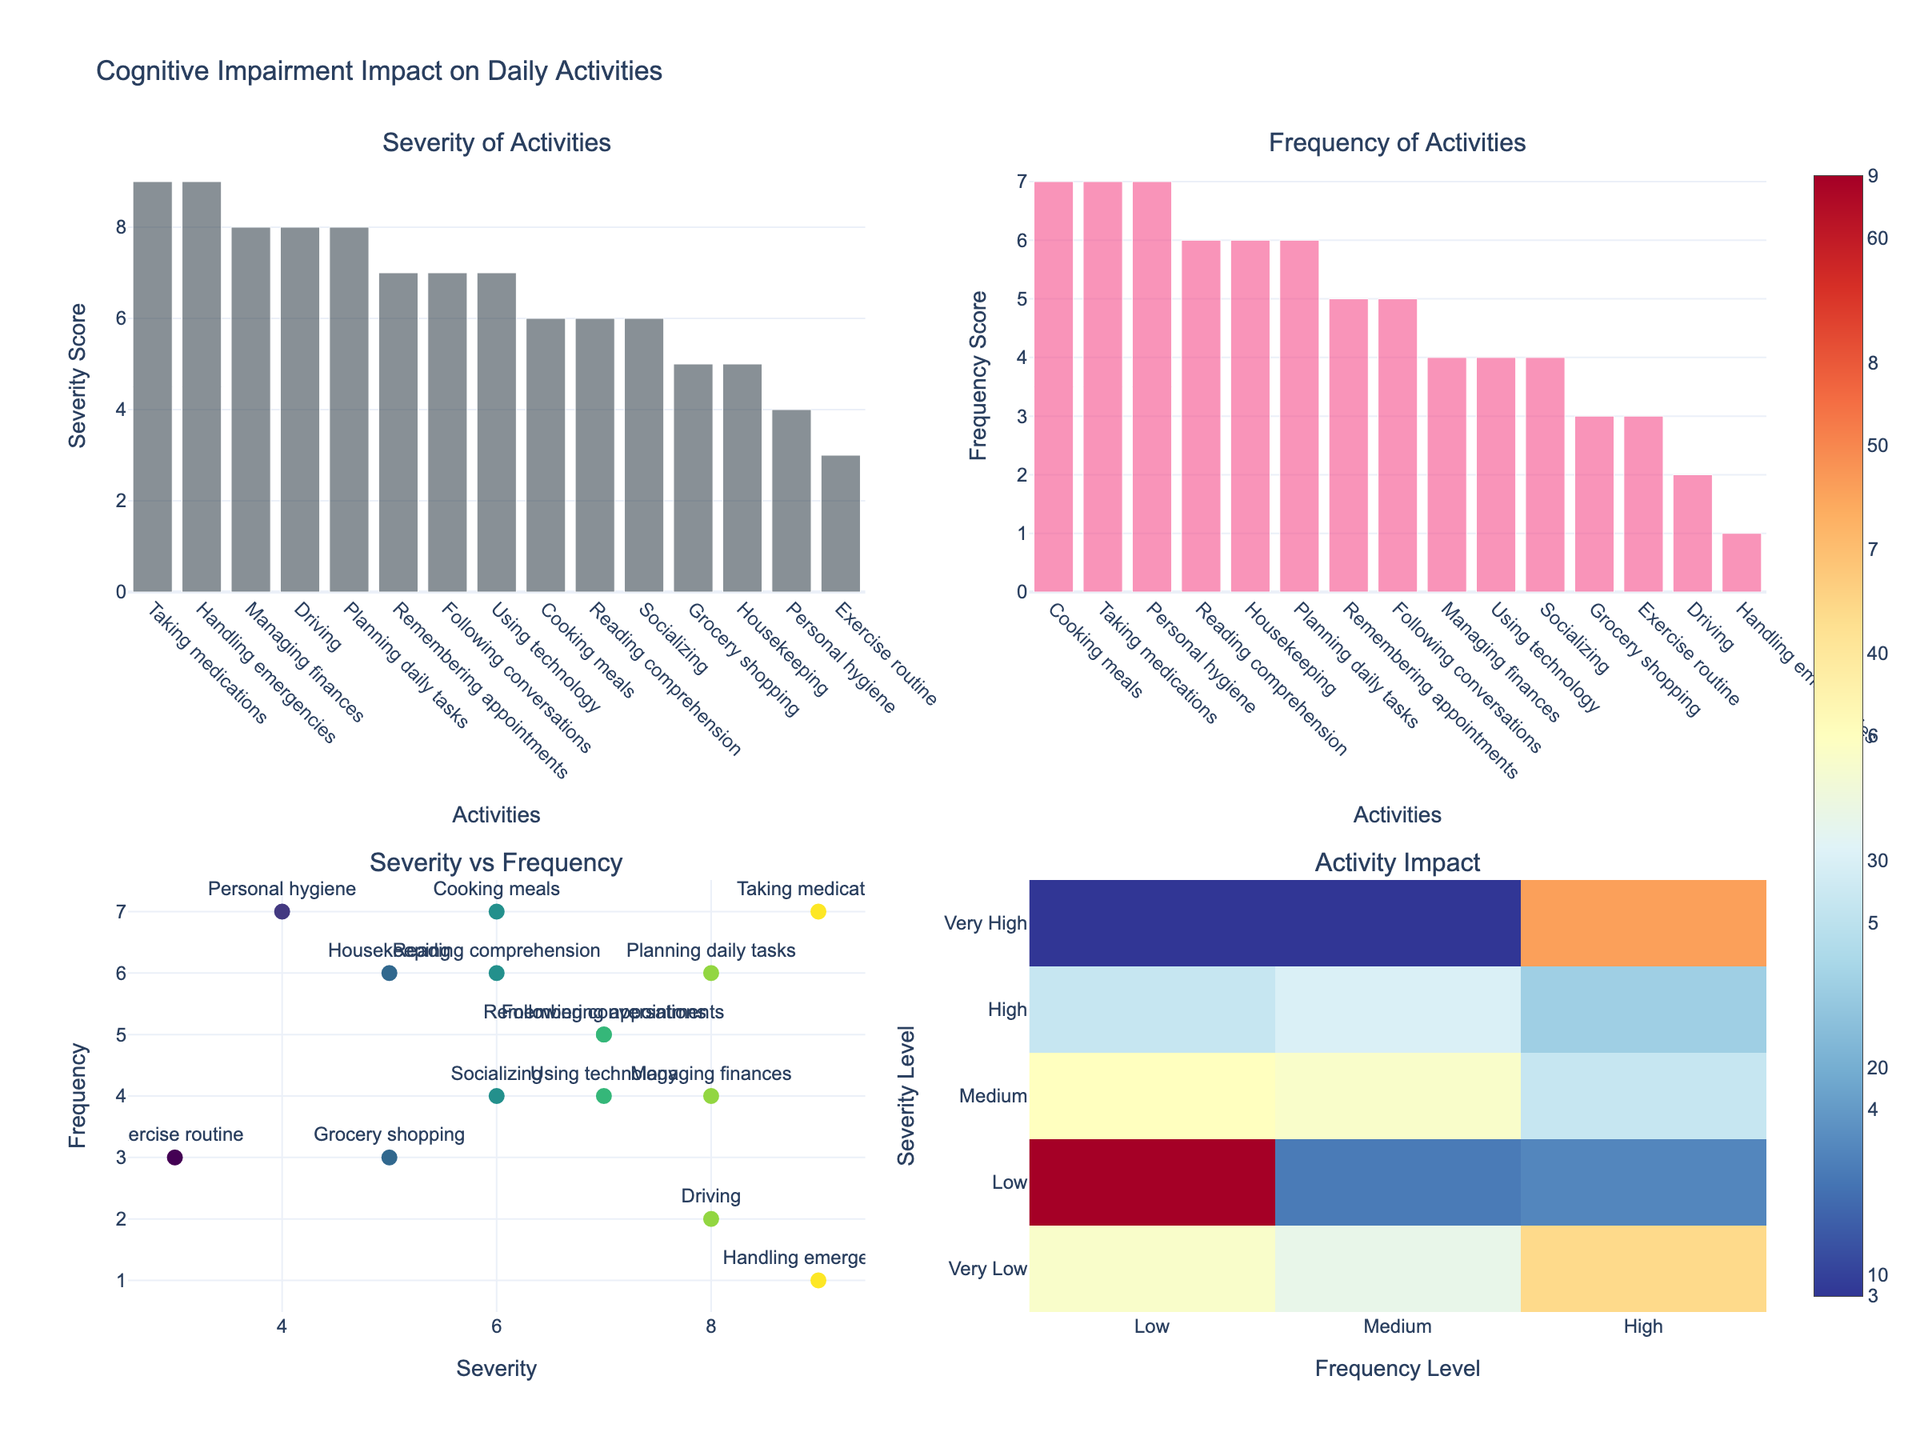What is the title of the figure? The title is usually located at the top of the plot, summarizing the contents. Here, it's located at the top.
Answer: Cognitive Impairment Impact on Daily Activities Which activity has the highest severity? To identify the activity with the highest severity, look at the first subplot (Severity of Activities) and find the tallest bar. This bar represents the activity with the highest severity score.
Answer: Taking medications What is the average frequency of daily activities? To find the average frequency, sum all the frequency values and divide by the number of activities. Frequencies are: 5, 4, 7, 7, 3, 2, 6, 5, 4, 7, 6, 4, 3, 1, and 6. Sum = 70. Number of activities = 15.
Answer: 4.67 Which activity appears to have the lowest impact according to the heatmap? In the fourth subplot (Activity Impact), the impact is shown as a heatmap with varying colors. The color represents the severity multiplied by the frequency. The lower left corner (darkest blue) often represents the lowest impact.
Answer: Handling emergencies How does the frequency of cooking meals compare to driving? In the second subplot (Frequency of Activities), locate the bars for cooking meals and driving, then compare their heights. Cooking meals has a taller bar.
Answer: Cooking meals has a higher frequency than driving Is there a correlation between severity and frequency for the given activities? Refer to the third subplot (Severity vs Frequency). If the points tend to rise together consistently, it indicates a positive correlation. Assess the trend of the points in the scatter plot.
Answer: Yes, there is a positive correlation Which activity has the highest combination of severity and frequency? To find the activity with the highest combined severity and frequency, look at the point farthest to the top-right in the third subplot (Severity vs Frequency). Might also check the heatmap's hottest color region.
Answer: Taking medications What are the severity and frequency levels for grocery shopping? Identify the grocery shopping bar in the first two subplots (Severity of Activities and Frequency of Activities) and note their heights or labels.
Answer: Severity: 5, Frequency: 3 Does planning daily tasks have a higher severity score than housekeeping? In the first subplot (Severity of Activities), compare the heights of the bars for planning daily tasks and housekeeping. Planning daily tasks have a taller bar.
Answer: Yes How are personal hygiene and socializing compared in terms of frequency? Refer to the second subplot (Frequency of Activities), find the bars for personal hygiene and socializing, and compare their heights. Personal hygiene has a taller bar.
Answer: Personal hygiene has a higher frequency 